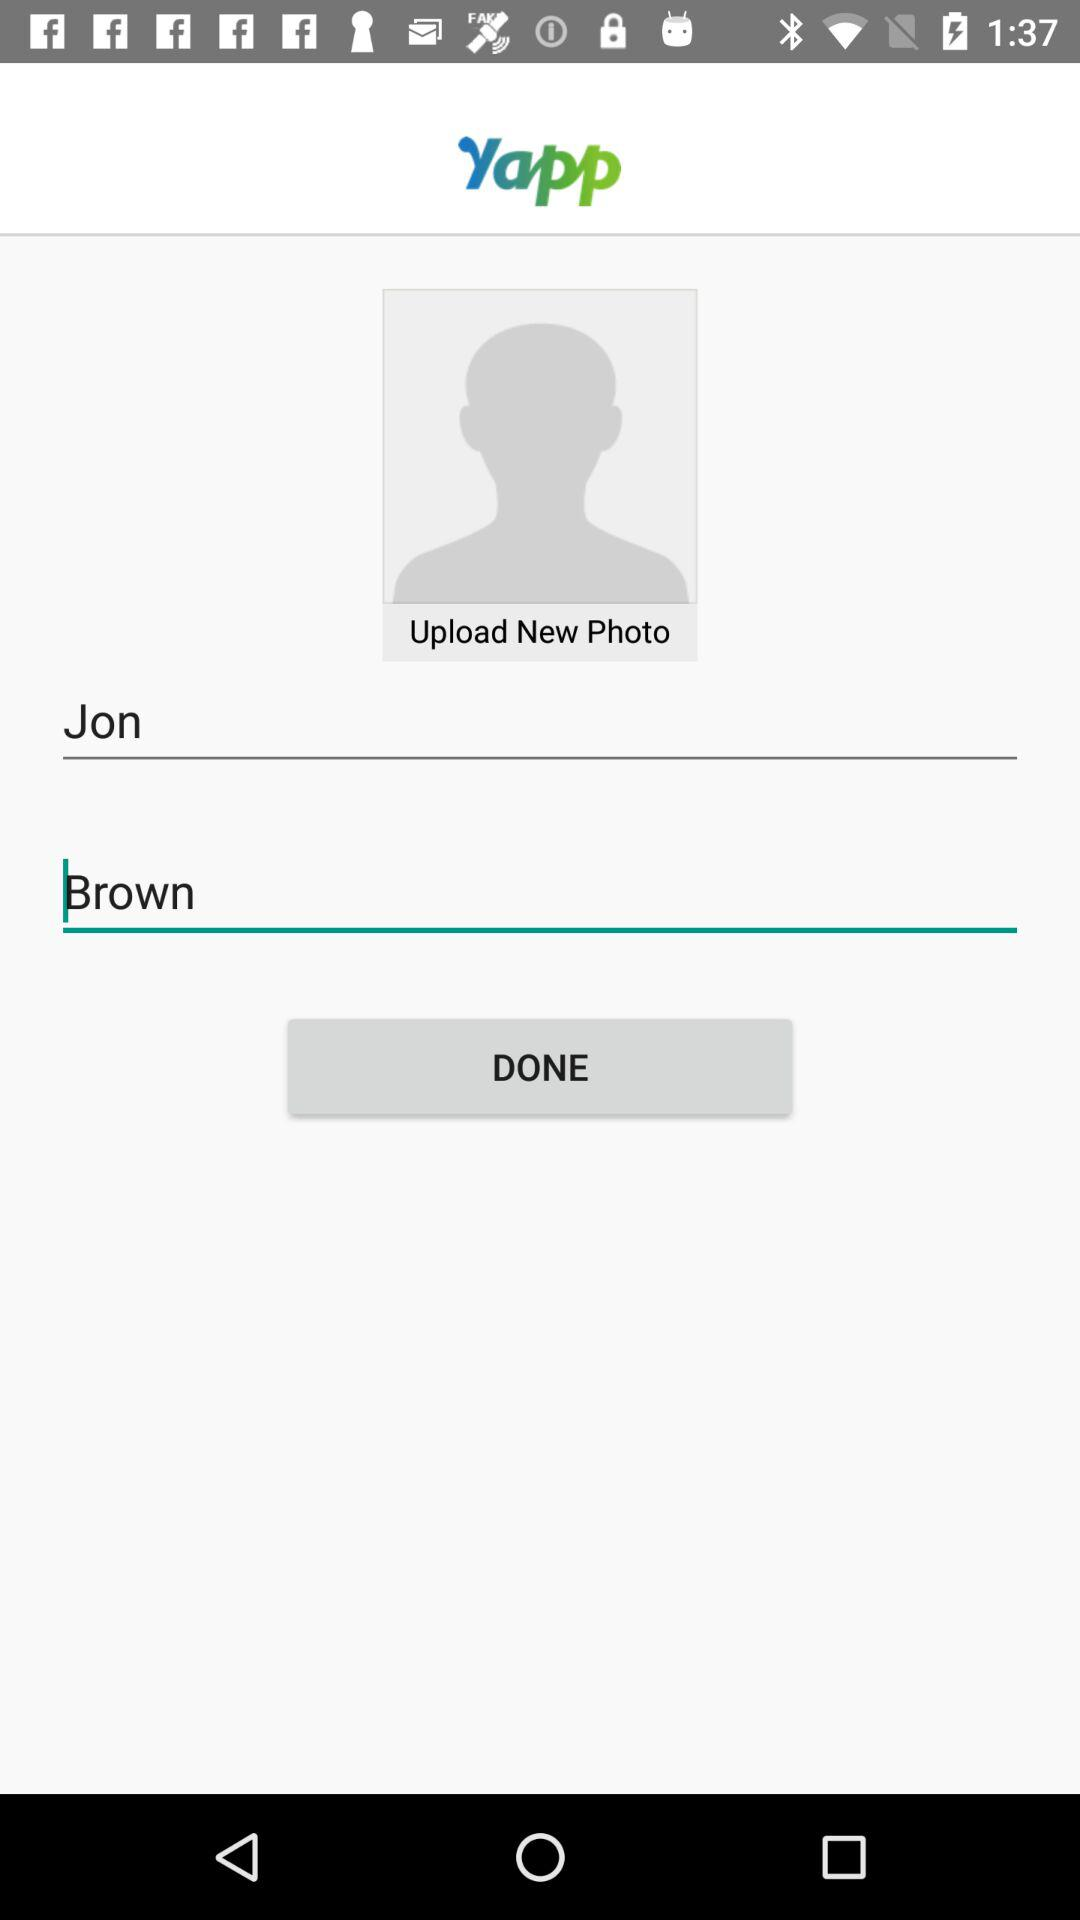What is the given last name? The given last name is Brown. 